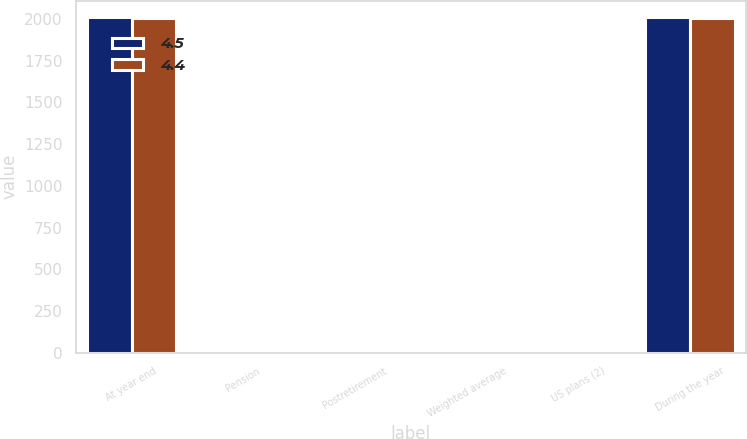<chart> <loc_0><loc_0><loc_500><loc_500><stacked_bar_chart><ecel><fcel>At year end<fcel>Pension<fcel>Postretirement<fcel>Weighted average<fcel>US plans (2)<fcel>During the year<nl><fcel>4.5<fcel>2009<fcel>5.9<fcel>5.55<fcel>6.5<fcel>3<fcel>2009<nl><fcel>4.4<fcel>2008<fcel>6.1<fcel>6<fcel>6.6<fcel>3<fcel>2008<nl></chart> 